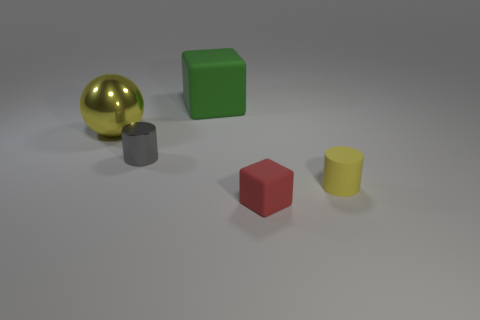What number of matte things are tiny cylinders or cyan blocks?
Offer a very short reply. 1. Is there a green block on the right side of the rubber cube that is in front of the matte cube that is behind the gray cylinder?
Provide a succinct answer. No. The large cube has what color?
Keep it short and to the point. Green. There is a small red object in front of the tiny gray object; does it have the same shape as the gray shiny thing?
Make the answer very short. No. How many things are green matte objects or yellow things that are to the left of the small metal cylinder?
Provide a succinct answer. 2. Does the object behind the big yellow shiny sphere have the same material as the small gray object?
Your answer should be very brief. No. Are there any other things that have the same size as the red object?
Make the answer very short. Yes. The cube that is behind the cube that is right of the large block is made of what material?
Offer a terse response. Rubber. Is the number of large green blocks to the right of the green object greater than the number of red rubber objects that are in front of the tiny red object?
Make the answer very short. No. How big is the green object?
Offer a terse response. Large. 